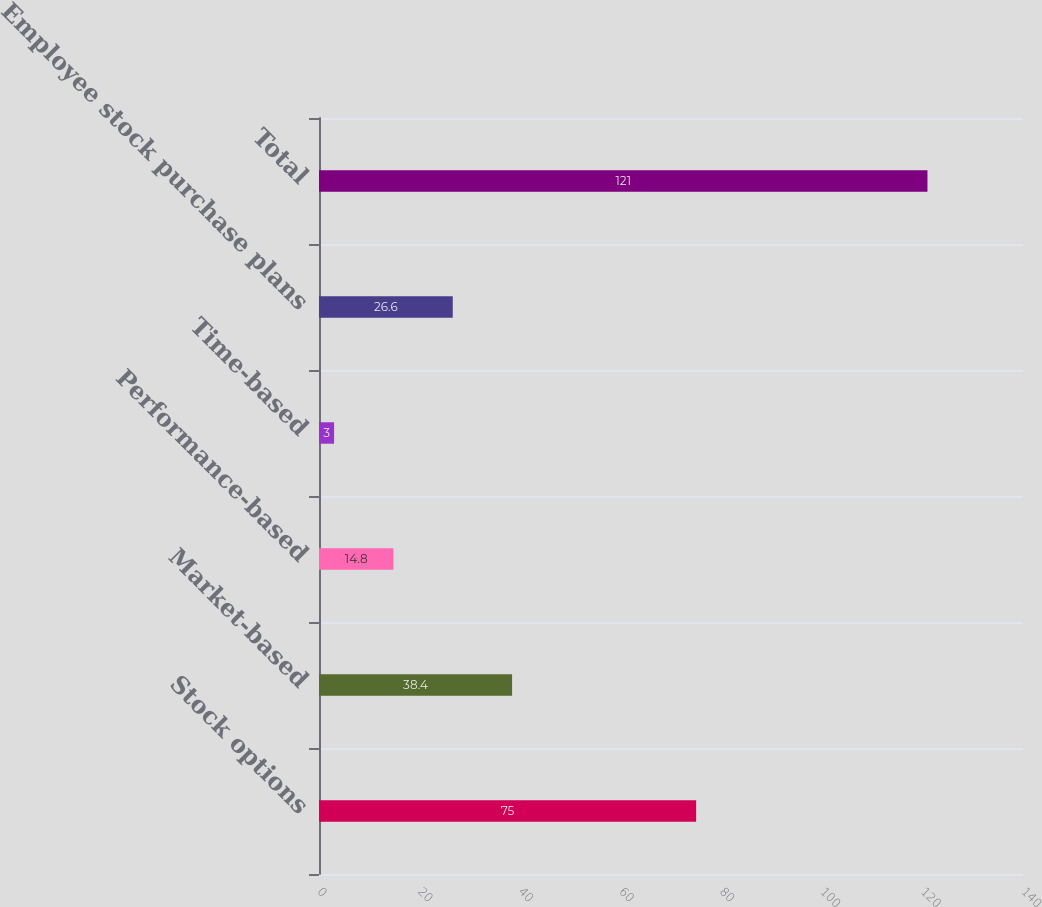Convert chart. <chart><loc_0><loc_0><loc_500><loc_500><bar_chart><fcel>Stock options<fcel>Market-based<fcel>Performance-based<fcel>Time-based<fcel>Employee stock purchase plans<fcel>Total<nl><fcel>75<fcel>38.4<fcel>14.8<fcel>3<fcel>26.6<fcel>121<nl></chart> 